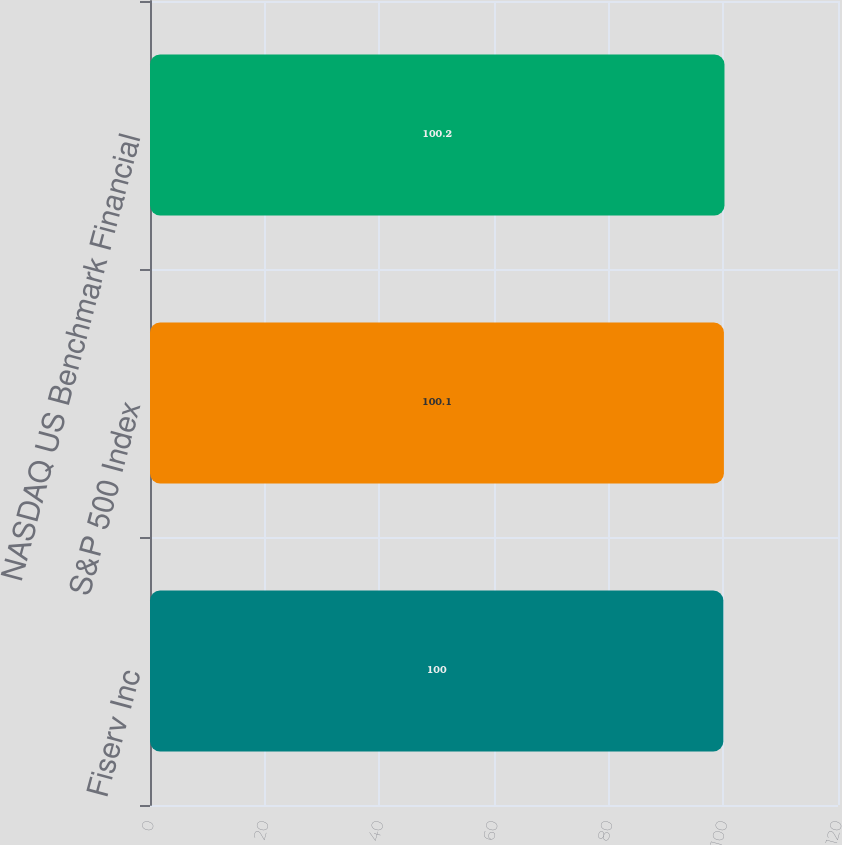Convert chart. <chart><loc_0><loc_0><loc_500><loc_500><bar_chart><fcel>Fiserv Inc<fcel>S&P 500 Index<fcel>NASDAQ US Benchmark Financial<nl><fcel>100<fcel>100.1<fcel>100.2<nl></chart> 